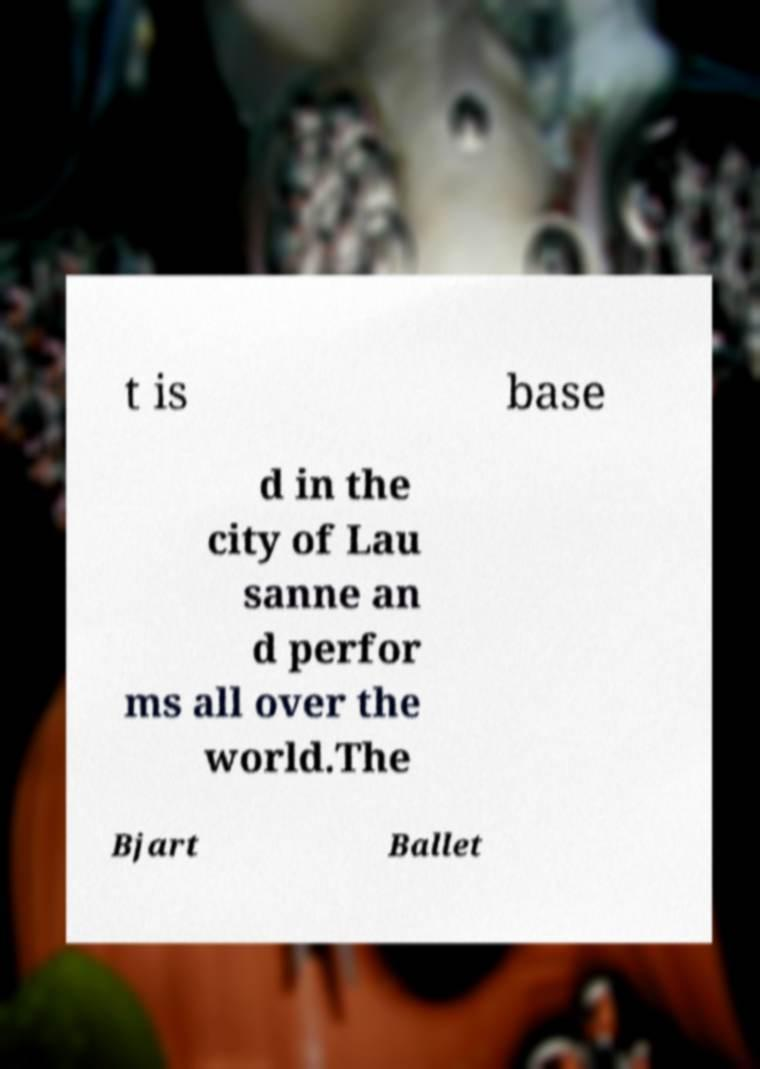Could you extract and type out the text from this image? t is base d in the city of Lau sanne an d perfor ms all over the world.The Bjart Ballet 